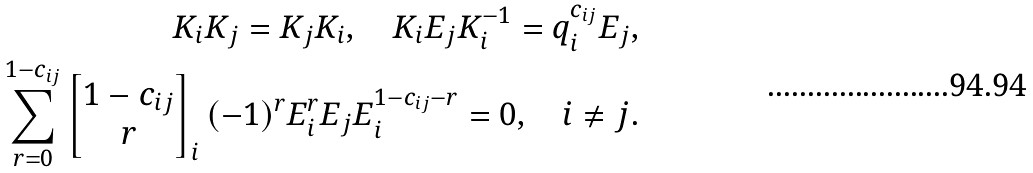Convert formula to latex. <formula><loc_0><loc_0><loc_500><loc_500>K _ { i } K _ { j } = K _ { j } K _ { i } , \quad K _ { i } E _ { j } K _ { i } ^ { - 1 } = q _ { i } ^ { c _ { i j } } E _ { j } , \\ \sum ^ { 1 - c _ { i j } } _ { r = 0 } \left [ \begin{matrix} 1 - c _ { i j } \\ r \end{matrix} \right ] _ { i } ( - 1 ) ^ { r } E _ { i } ^ { r } E _ { j } E _ { i } ^ { 1 - c _ { i j } - r } = 0 , \quad i \neq j .</formula> 